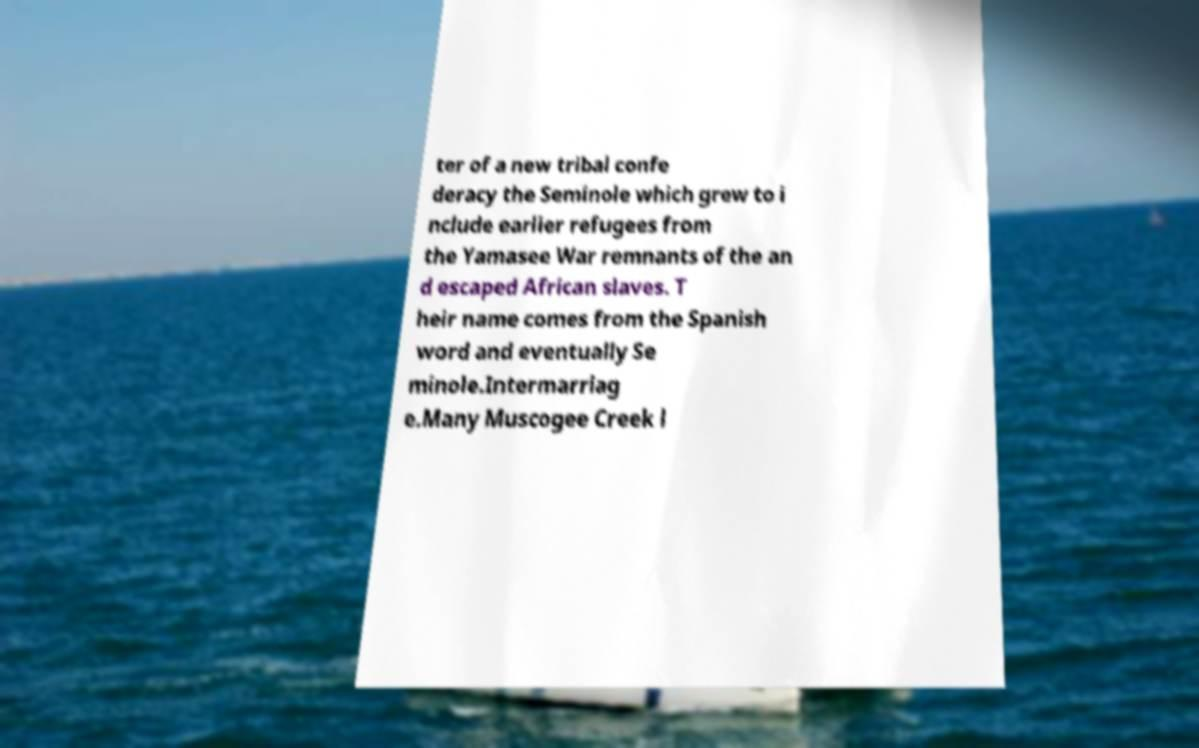Please read and relay the text visible in this image. What does it say? ter of a new tribal confe deracy the Seminole which grew to i nclude earlier refugees from the Yamasee War remnants of the an d escaped African slaves. T heir name comes from the Spanish word and eventually Se minole.Intermarriag e.Many Muscogee Creek l 